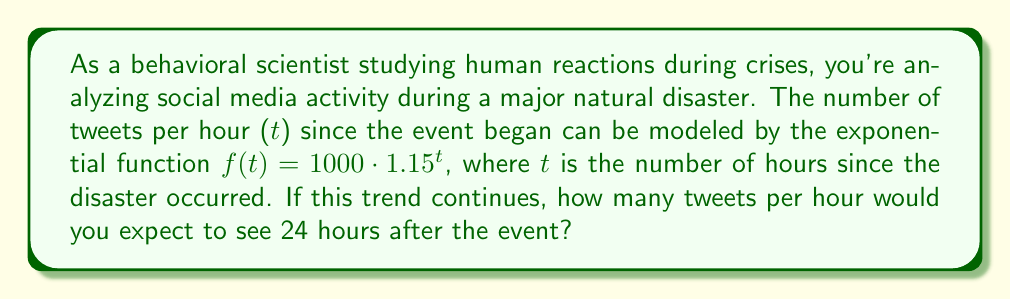Could you help me with this problem? To solve this problem, we need to use the given exponential function and evaluate it at t = 24 hours. Let's break it down step-by-step:

1. The given exponential function is:
   $f(t) = 1000 \cdot 1.15^t$

2. We need to find $f(24)$, so we substitute t = 24 into the function:
   $f(24) = 1000 \cdot 1.15^{24}$

3. Now, we need to calculate $1.15^{24}$. This can be done using a calculator or by breaking it down:
   $1.15^{24} = (1.15^4)^6 \approx 2.0114^6 \approx 64.6407$

4. Multiply this result by 1000:
   $f(24) = 1000 \cdot 64.6407 \approx 64,640.7$

5. Round to the nearest whole number, as we're dealing with tweets:
   $f(24) \approx 64,641$

This result shows the exponential growth in social media activity during a crisis, which is a common pattern observed by behavioral scientists studying human reactions to major events.
Answer: Approximately 64,641 tweets per hour 